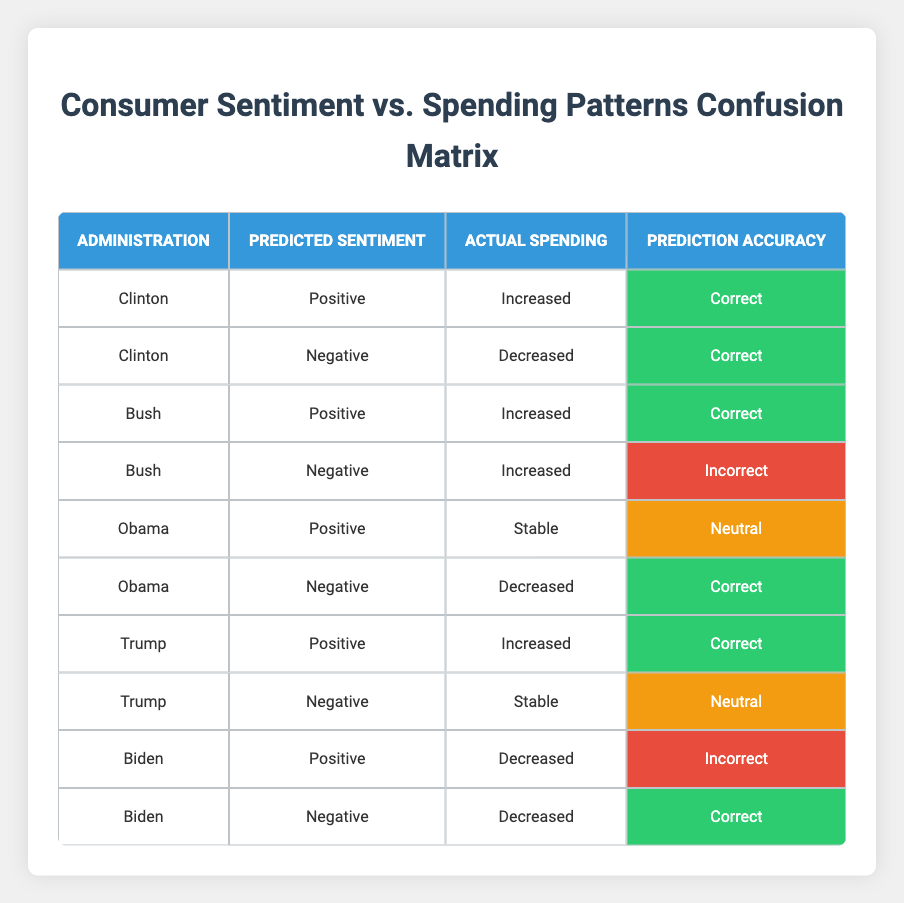What was the predicted sentiment for Obama when the actual spending was stable? According to the table, when Obama's actual spending was stable, the predicted sentiment was positive.
Answer: Positive How many administrations showed a correct prediction for both positive and negative sentiments? The administrations showing correct predictions for both sentiments are Clinton, Bush, Obama, and Trump. Each of these has one correct prediction for both their positive and negative sentiment categories. Therefore, there are four administrations.
Answer: 4 Did Biden's predicted positive sentiment correspond to an actual increase in spending? Yes, Biden's predicted positive sentiment did not correspond to an actual increase in spending; rather, it corresponded to a decrease in spending.
Answer: No Which administration had an incorrect prediction for its negative sentiment and what was the actual spending response? Bush had an incorrect prediction for its negative sentiment, and the actual spending response was increased.
Answer: Bush, Increased What is the total number of predictions made for the Trump administration, and how many of them were deemed correct? There were two predictions made for the Trump administration, one positive (correct) and one negative (neutral). Thus, only one out of the two predictions was correct.
Answer: 2 predictions, 1 correct Was there a correlation where positive predicted sentiments consistently led to increased actual spending across all administrations? The only administrations where a positive predicted sentiment led to increased actual spending were Clinton, Bush, and Trump. However, Obama's positive sentiment led to stable spending, and Biden's led to decreased spending. Hence, there is no consistent correlation.
Answer: No How many total predictions resulted in a "Neutral" evaluation in the table? The table shows that there were two predictions with a neutral evaluation: Obama's positive sentiment and Trump's negative sentiment. Therefore, the total is two.
Answer: 2 What percentage of the overall predictions were classified as correct? There are ten total predictions, and six are classified as correct. The percentage is calculated as (6/10) * 100, which equals 60%.
Answer: 60% 